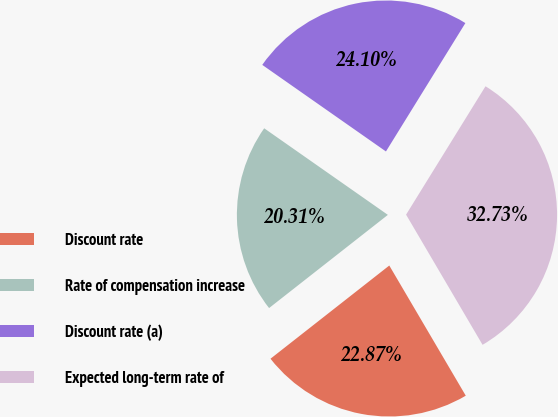Convert chart to OTSL. <chart><loc_0><loc_0><loc_500><loc_500><pie_chart><fcel>Discount rate<fcel>Rate of compensation increase<fcel>Discount rate (a)<fcel>Expected long-term rate of<nl><fcel>22.87%<fcel>20.31%<fcel>24.1%<fcel>32.73%<nl></chart> 